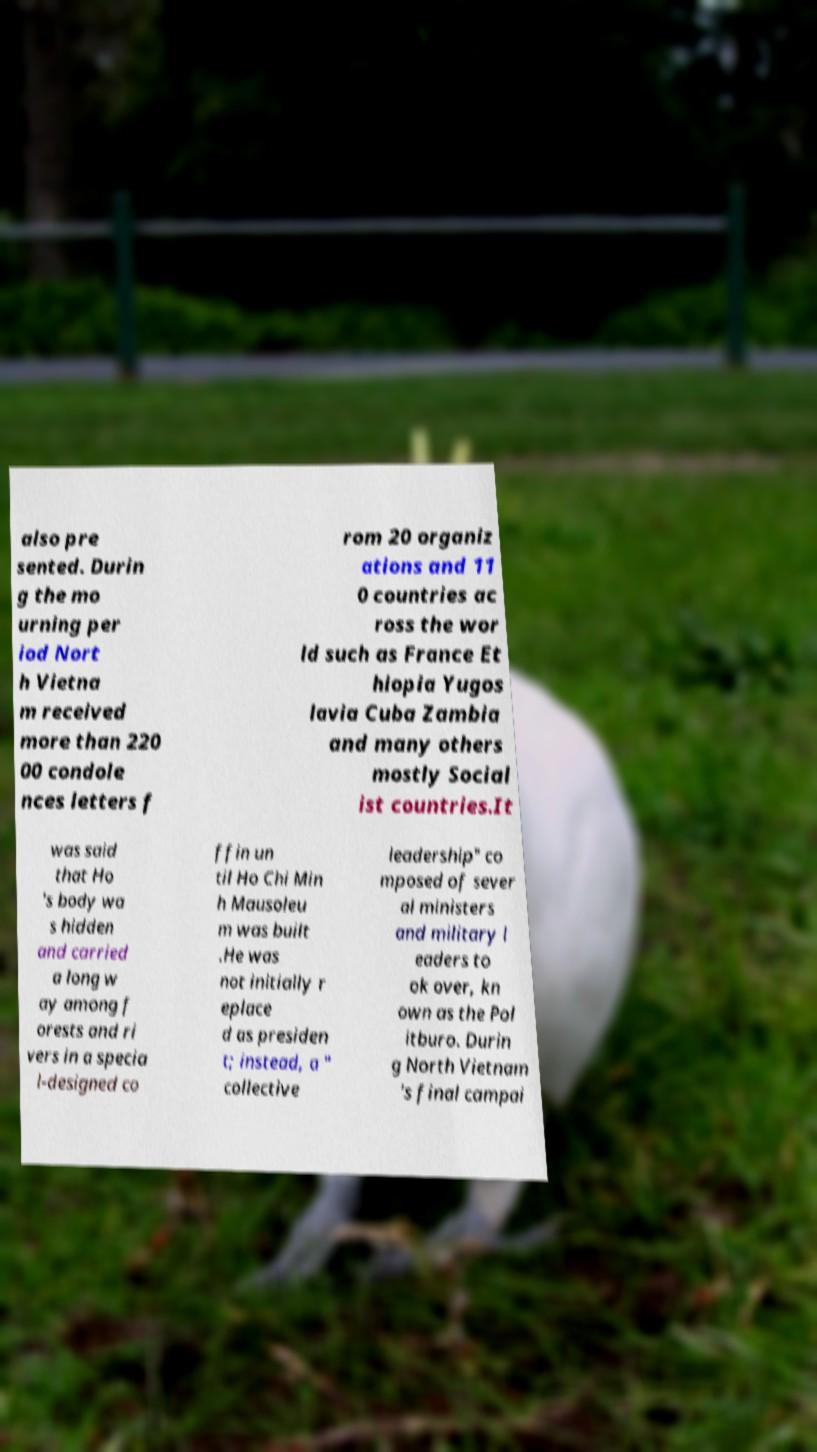For documentation purposes, I need the text within this image transcribed. Could you provide that? also pre sented. Durin g the mo urning per iod Nort h Vietna m received more than 220 00 condole nces letters f rom 20 organiz ations and 11 0 countries ac ross the wor ld such as France Et hiopia Yugos lavia Cuba Zambia and many others mostly Social ist countries.It was said that Ho 's body wa s hidden and carried a long w ay among f orests and ri vers in a specia l-designed co ffin un til Ho Chi Min h Mausoleu m was built .He was not initially r eplace d as presiden t; instead, a " collective leadership" co mposed of sever al ministers and military l eaders to ok over, kn own as the Pol itburo. Durin g North Vietnam 's final campai 